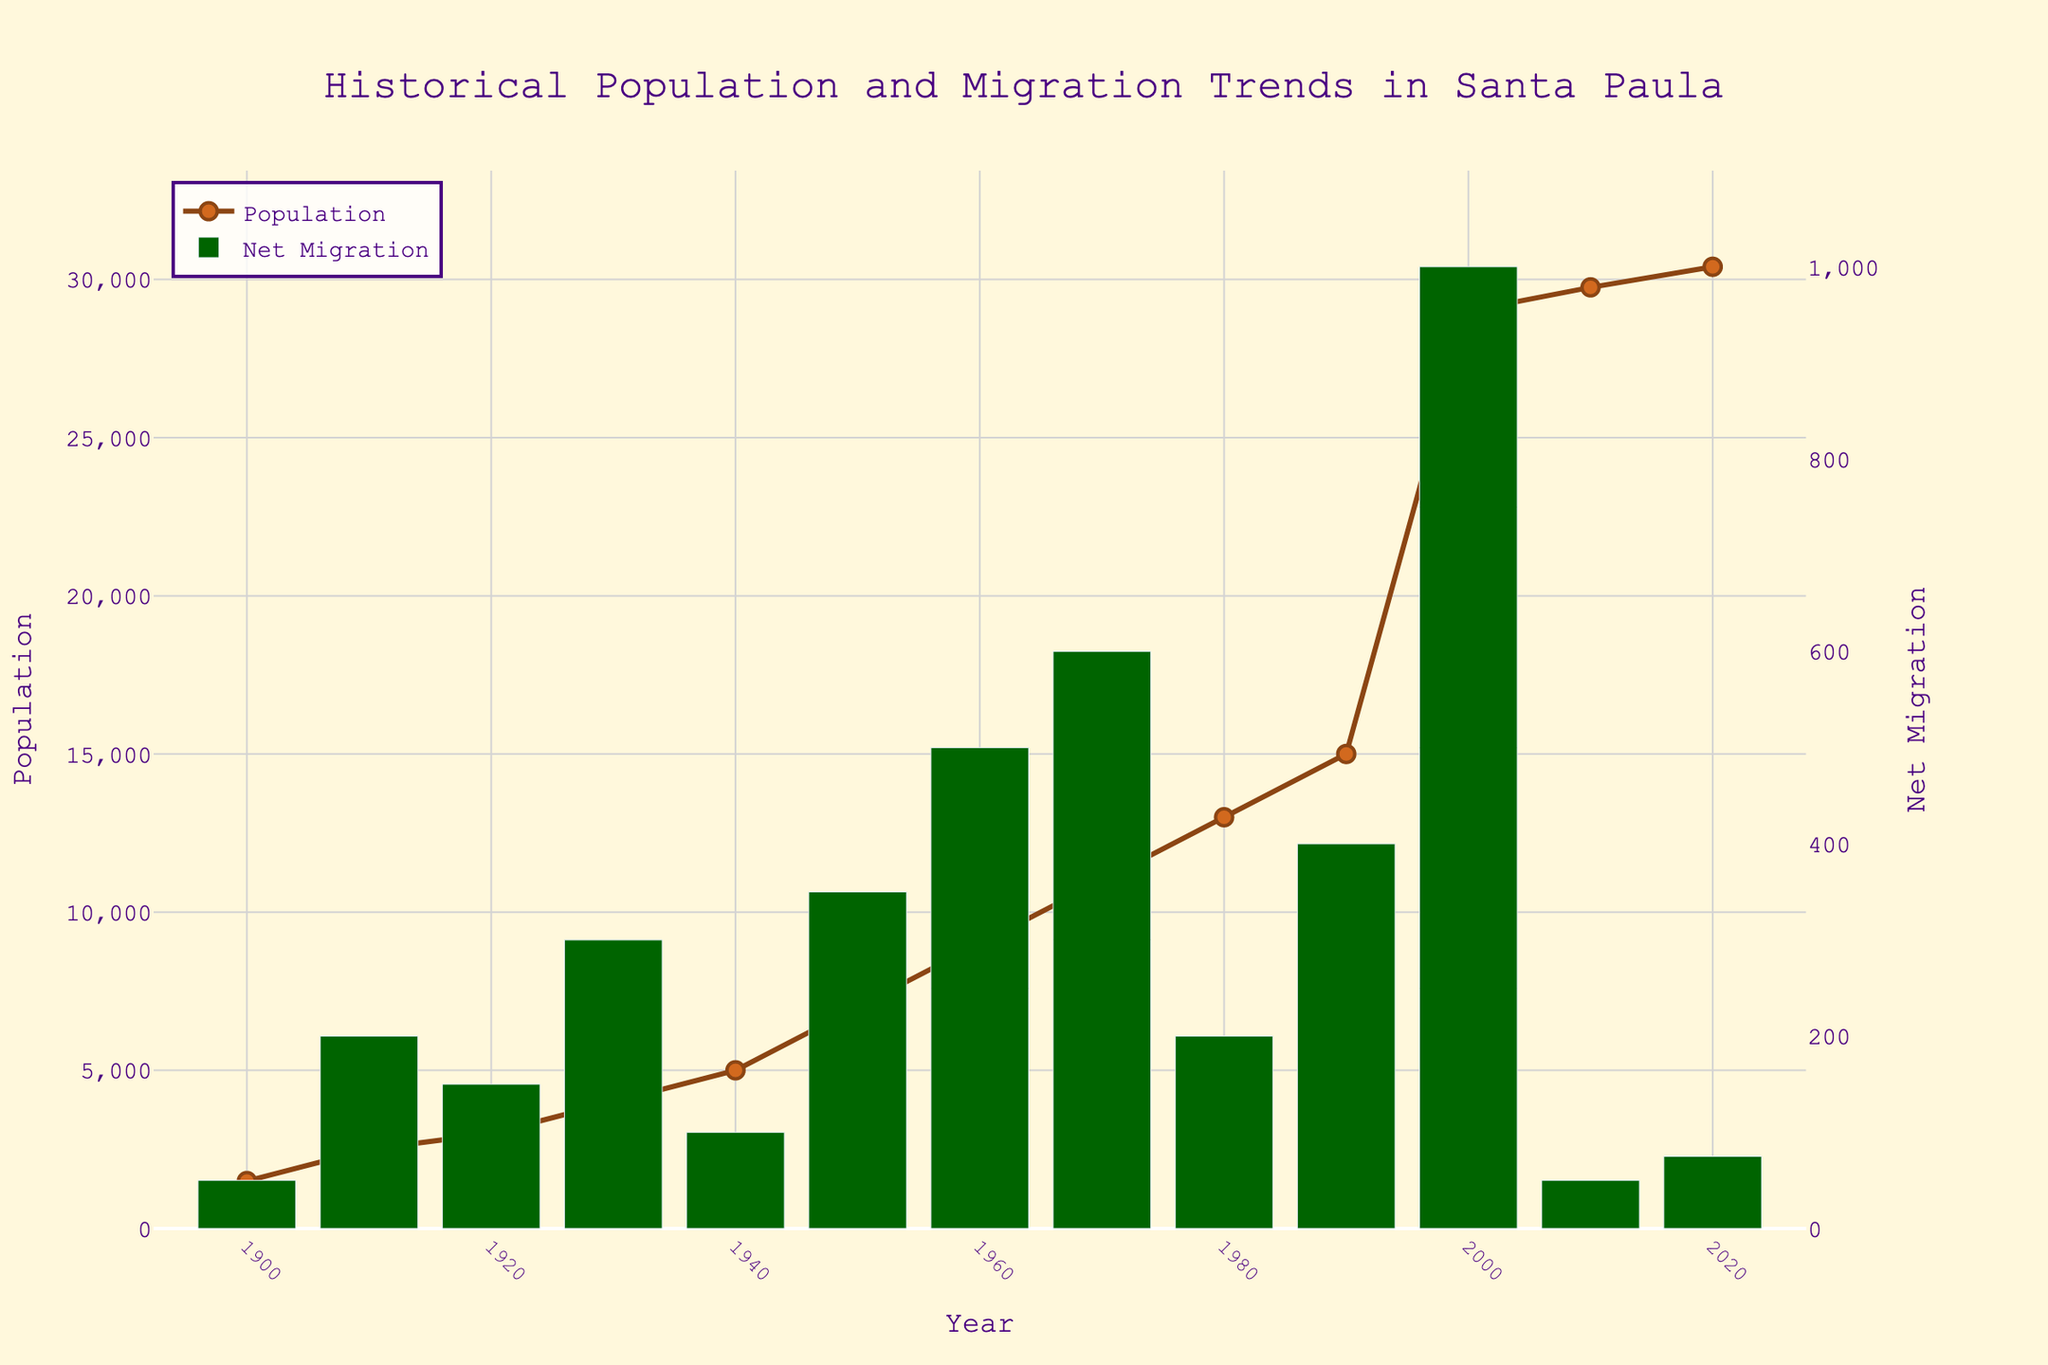How many years have been tracked in the figure? The x-axis lists the years from 1900 to 2020. Counting these years, there are 13 specific years tracked.
Answer: 13 What is the title of the figure? The title of the figure is positioned at the top of the plot and reads, "Historical Population and Migration Trends in Santa Paula."
Answer: "Historical Population and Migration Trends in Santa Paula" Which year experienced the highest net migration according to the figure? By examining the bar heights, the year 2000 has the tallest bar indicating the highest net migration.
Answer: 2000 How does the population in 1930 compare to the population in 2020? The population in 1930 is 4000, as per the line tracking Population, whereas in 2020, it is 30400. Hence, the population in 2020 is significantly higher than in 1930.
Answer: Higher What's the difference in population between 2000 and 2010? In 2000, the population is 29000, and in 2010, it is 29750. The difference is 29750 - 29000 = 750.
Answer: 750 What was the population growth between the years 1980 and 1990? The population in 1980 is 13000 and in 1990 it is 15000. The growth is 15000 - 13000 = 2000.
Answer: 2000 In how many years is the net migration value greater than 500? The histogram shows that net migration values exceed 500 in the years 1960, 1970, and 2000, making it a total of 3 years.
Answer: 3 Which year had the lowest net migration? The smallest bar in the Net Migration trace appears in 1900, with a value of 50.
Answer: 1900 What color is used to represent the population line in the figure? The population line is represented by a brownish shade in the figure.
Answer: Brown When did Santa Paula see its biggest population increment within a decade? By comparing the differences across the decades, the largest increment occurred between 1990 (15000) and 2000 (29000), where the increase was 29000 - 15000 = 14000.
Answer: Between 1990 and 2000 